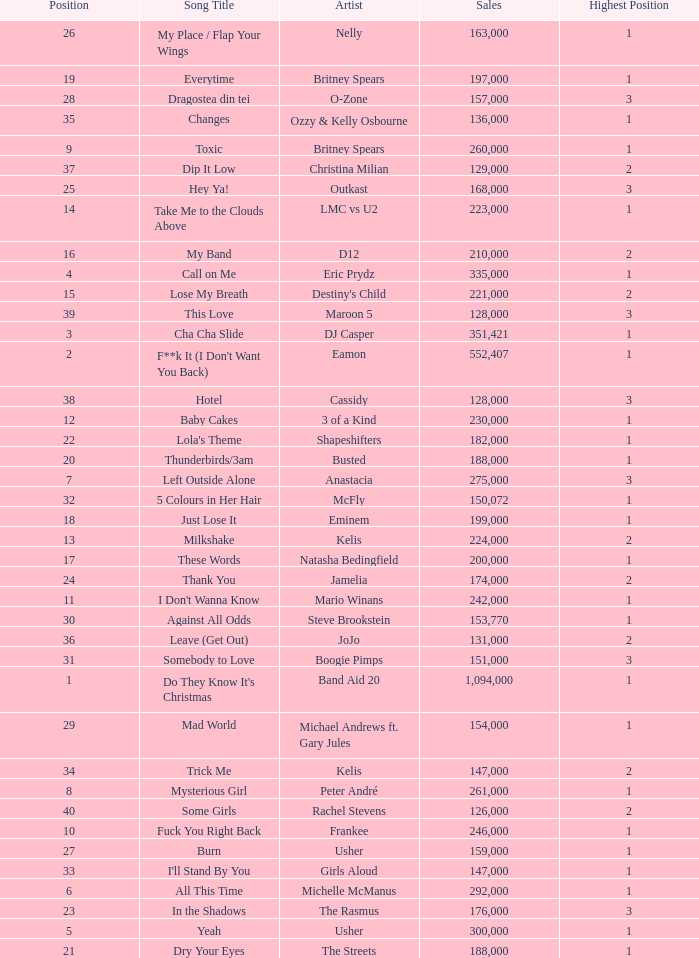What were the sales for Dj Casper when he was in a position lower than 13? 351421.0. 